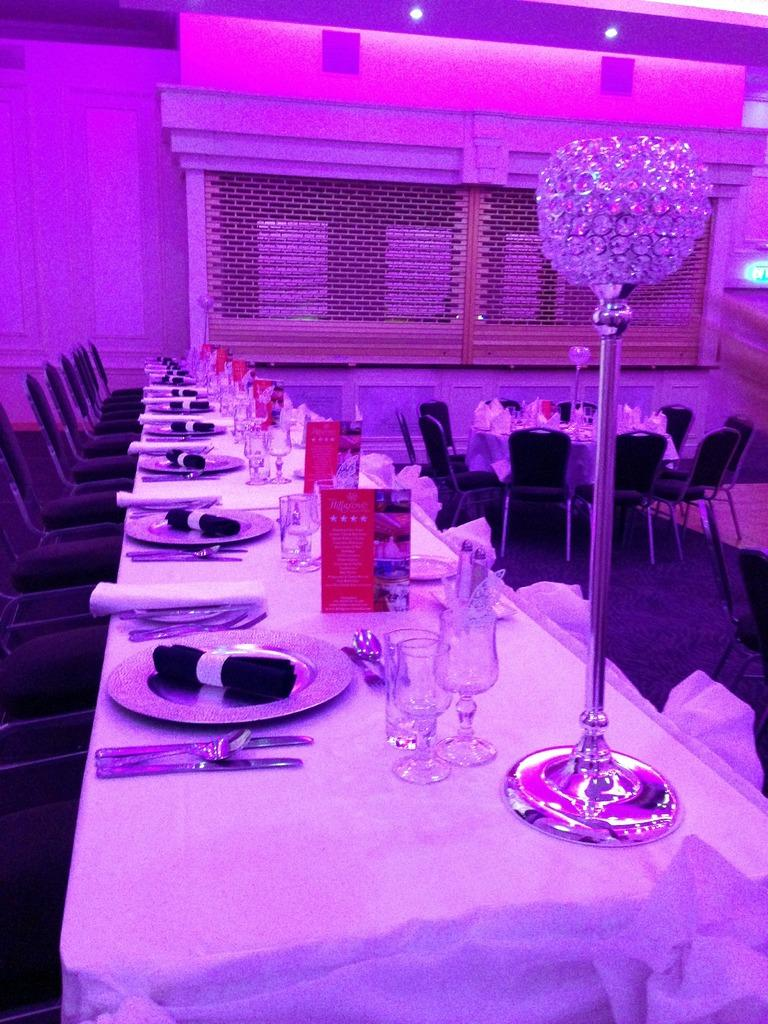What type of objects can be seen on the table in the image? There are plates, cloths, cards, glasses, spoons, and knives visible on the table in the image. What type of furniture is present in the background of the image? There are chairs in the background of the image. What type of lighting is present in the background of the image? There are lights in the background of the image. What type of surface is visible in the background of the image? There is a table in the background of the image. What type of pizzas are being served on the table in the image? There are no pizzas present in the image; the table contains plates, cloths, cards, glasses, spoons, and knives. 